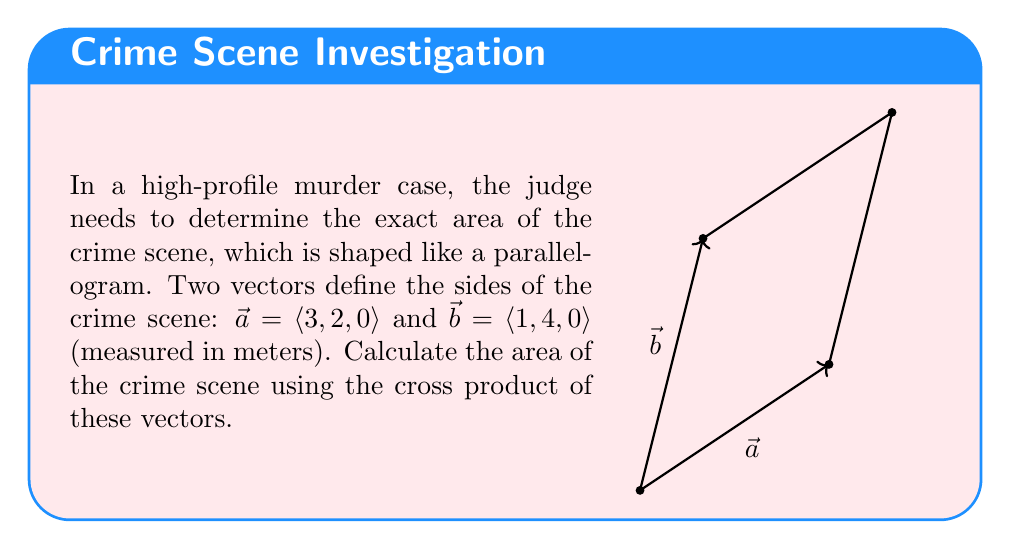Show me your answer to this math problem. To find the area of the parallelogram-shaped crime scene, we need to calculate the magnitude of the cross product of vectors $\vec{a}$ and $\vec{b}$. The steps are as follows:

1) The cross product of two vectors $\vec{a} = \langle a_1, a_2, a_3 \rangle$ and $\vec{b} = \langle b_1, b_2, b_3 \rangle$ is given by:

   $$\vec{a} \times \vec{b} = \langle a_2b_3 - a_3b_2, a_3b_1 - a_1b_3, a_1b_2 - a_2b_1 \rangle$$

2) Substituting the given vectors:
   $\vec{a} = \langle 3, 2, 0 \rangle$ and $\vec{b} = \langle 1, 4, 0 \rangle$

3) Calculating the cross product:
   $$\vec{a} \times \vec{b} = \langle (2)(0) - (0)(4), (0)(1) - (3)(0), (3)(4) - (2)(1) \rangle$$

4) Simplifying:
   $$\vec{a} \times \vec{b} = \langle 0, 0, 12 - 2 \rangle = \langle 0, 0, 10 \rangle$$

5) The magnitude of this cross product vector gives the area of the parallelogram:
   $$\text{Area} = |\vec{a} \times \vec{b}| = \sqrt{0^2 + 0^2 + 10^2} = 10$$

Therefore, the area of the crime scene is 10 square meters.
Answer: 10 m² 